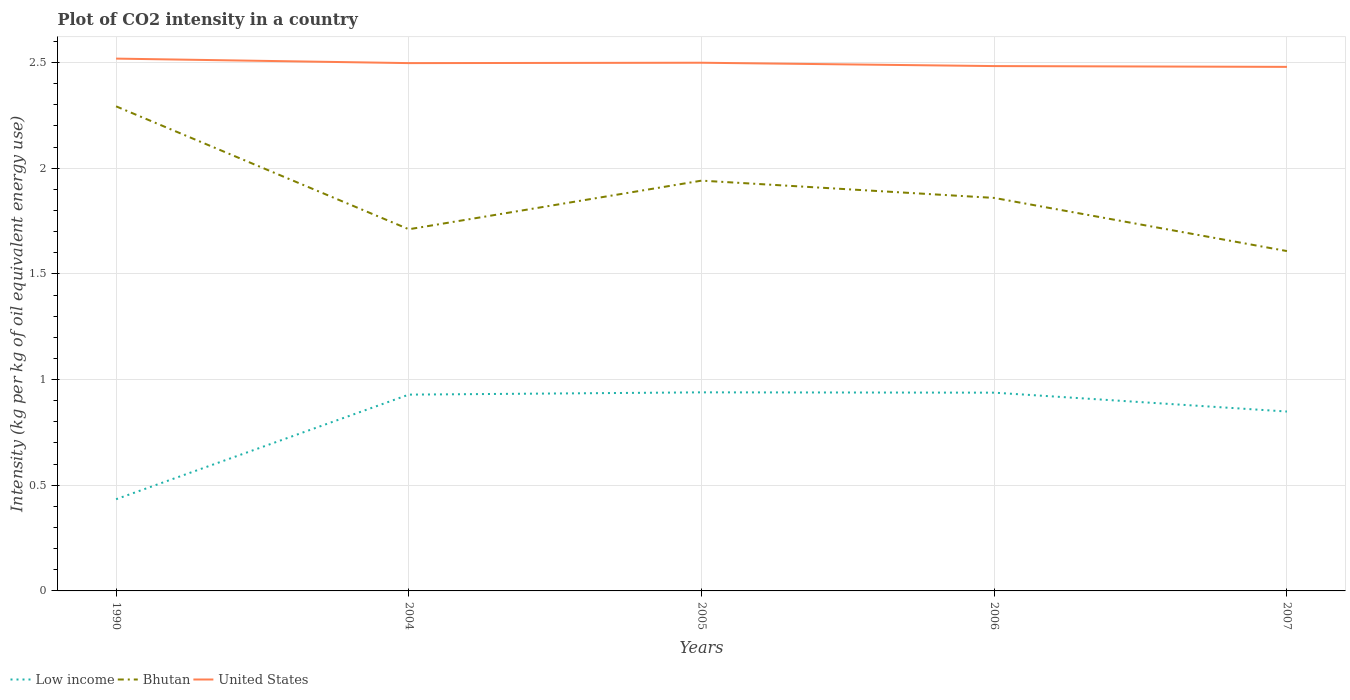How many different coloured lines are there?
Offer a very short reply. 3. Is the number of lines equal to the number of legend labels?
Make the answer very short. Yes. Across all years, what is the maximum CO2 intensity in in Low income?
Ensure brevity in your answer.  0.43. What is the total CO2 intensity in in Bhutan in the graph?
Provide a succinct answer. 0.58. What is the difference between the highest and the second highest CO2 intensity in in United States?
Your response must be concise. 0.04. What is the difference between the highest and the lowest CO2 intensity in in Bhutan?
Provide a short and direct response. 2. How many lines are there?
Ensure brevity in your answer.  3. What is the difference between two consecutive major ticks on the Y-axis?
Your answer should be compact. 0.5. Does the graph contain any zero values?
Offer a terse response. No. Does the graph contain grids?
Your response must be concise. Yes. Where does the legend appear in the graph?
Your answer should be very brief. Bottom left. How many legend labels are there?
Offer a terse response. 3. What is the title of the graph?
Your answer should be compact. Plot of CO2 intensity in a country. What is the label or title of the X-axis?
Your answer should be compact. Years. What is the label or title of the Y-axis?
Offer a very short reply. Intensity (kg per kg of oil equivalent energy use). What is the Intensity (kg per kg of oil equivalent energy use) of Low income in 1990?
Offer a very short reply. 0.43. What is the Intensity (kg per kg of oil equivalent energy use) of Bhutan in 1990?
Ensure brevity in your answer.  2.29. What is the Intensity (kg per kg of oil equivalent energy use) in United States in 1990?
Your response must be concise. 2.52. What is the Intensity (kg per kg of oil equivalent energy use) in Low income in 2004?
Provide a short and direct response. 0.93. What is the Intensity (kg per kg of oil equivalent energy use) of Bhutan in 2004?
Make the answer very short. 1.71. What is the Intensity (kg per kg of oil equivalent energy use) of United States in 2004?
Your answer should be very brief. 2.5. What is the Intensity (kg per kg of oil equivalent energy use) in Low income in 2005?
Provide a succinct answer. 0.94. What is the Intensity (kg per kg of oil equivalent energy use) in Bhutan in 2005?
Your answer should be very brief. 1.94. What is the Intensity (kg per kg of oil equivalent energy use) in United States in 2005?
Offer a very short reply. 2.5. What is the Intensity (kg per kg of oil equivalent energy use) of Low income in 2006?
Provide a succinct answer. 0.94. What is the Intensity (kg per kg of oil equivalent energy use) of Bhutan in 2006?
Offer a very short reply. 1.86. What is the Intensity (kg per kg of oil equivalent energy use) in United States in 2006?
Keep it short and to the point. 2.48. What is the Intensity (kg per kg of oil equivalent energy use) in Low income in 2007?
Your answer should be compact. 0.85. What is the Intensity (kg per kg of oil equivalent energy use) in Bhutan in 2007?
Your response must be concise. 1.61. What is the Intensity (kg per kg of oil equivalent energy use) of United States in 2007?
Provide a succinct answer. 2.48. Across all years, what is the maximum Intensity (kg per kg of oil equivalent energy use) of Low income?
Provide a succinct answer. 0.94. Across all years, what is the maximum Intensity (kg per kg of oil equivalent energy use) in Bhutan?
Your answer should be compact. 2.29. Across all years, what is the maximum Intensity (kg per kg of oil equivalent energy use) of United States?
Offer a very short reply. 2.52. Across all years, what is the minimum Intensity (kg per kg of oil equivalent energy use) in Low income?
Your answer should be very brief. 0.43. Across all years, what is the minimum Intensity (kg per kg of oil equivalent energy use) in Bhutan?
Your response must be concise. 1.61. Across all years, what is the minimum Intensity (kg per kg of oil equivalent energy use) of United States?
Your answer should be very brief. 2.48. What is the total Intensity (kg per kg of oil equivalent energy use) in Low income in the graph?
Your answer should be compact. 4.09. What is the total Intensity (kg per kg of oil equivalent energy use) in Bhutan in the graph?
Offer a very short reply. 9.41. What is the total Intensity (kg per kg of oil equivalent energy use) of United States in the graph?
Your response must be concise. 12.48. What is the difference between the Intensity (kg per kg of oil equivalent energy use) in Low income in 1990 and that in 2004?
Your response must be concise. -0.49. What is the difference between the Intensity (kg per kg of oil equivalent energy use) of Bhutan in 1990 and that in 2004?
Your response must be concise. 0.58. What is the difference between the Intensity (kg per kg of oil equivalent energy use) in United States in 1990 and that in 2004?
Keep it short and to the point. 0.02. What is the difference between the Intensity (kg per kg of oil equivalent energy use) of Low income in 1990 and that in 2005?
Ensure brevity in your answer.  -0.51. What is the difference between the Intensity (kg per kg of oil equivalent energy use) in Bhutan in 1990 and that in 2005?
Keep it short and to the point. 0.35. What is the difference between the Intensity (kg per kg of oil equivalent energy use) in United States in 1990 and that in 2005?
Offer a very short reply. 0.02. What is the difference between the Intensity (kg per kg of oil equivalent energy use) in Low income in 1990 and that in 2006?
Provide a short and direct response. -0.5. What is the difference between the Intensity (kg per kg of oil equivalent energy use) in Bhutan in 1990 and that in 2006?
Make the answer very short. 0.43. What is the difference between the Intensity (kg per kg of oil equivalent energy use) in United States in 1990 and that in 2006?
Offer a terse response. 0.04. What is the difference between the Intensity (kg per kg of oil equivalent energy use) in Low income in 1990 and that in 2007?
Your answer should be very brief. -0.41. What is the difference between the Intensity (kg per kg of oil equivalent energy use) in Bhutan in 1990 and that in 2007?
Your answer should be compact. 0.68. What is the difference between the Intensity (kg per kg of oil equivalent energy use) in United States in 1990 and that in 2007?
Keep it short and to the point. 0.04. What is the difference between the Intensity (kg per kg of oil equivalent energy use) of Low income in 2004 and that in 2005?
Provide a short and direct response. -0.01. What is the difference between the Intensity (kg per kg of oil equivalent energy use) in Bhutan in 2004 and that in 2005?
Keep it short and to the point. -0.23. What is the difference between the Intensity (kg per kg of oil equivalent energy use) in United States in 2004 and that in 2005?
Your answer should be very brief. -0. What is the difference between the Intensity (kg per kg of oil equivalent energy use) of Low income in 2004 and that in 2006?
Your response must be concise. -0.01. What is the difference between the Intensity (kg per kg of oil equivalent energy use) of Bhutan in 2004 and that in 2006?
Your answer should be compact. -0.15. What is the difference between the Intensity (kg per kg of oil equivalent energy use) of United States in 2004 and that in 2006?
Offer a very short reply. 0.01. What is the difference between the Intensity (kg per kg of oil equivalent energy use) in Bhutan in 2004 and that in 2007?
Your answer should be compact. 0.1. What is the difference between the Intensity (kg per kg of oil equivalent energy use) of United States in 2004 and that in 2007?
Ensure brevity in your answer.  0.02. What is the difference between the Intensity (kg per kg of oil equivalent energy use) in Low income in 2005 and that in 2006?
Provide a succinct answer. 0. What is the difference between the Intensity (kg per kg of oil equivalent energy use) of Bhutan in 2005 and that in 2006?
Provide a succinct answer. 0.08. What is the difference between the Intensity (kg per kg of oil equivalent energy use) of United States in 2005 and that in 2006?
Your answer should be very brief. 0.02. What is the difference between the Intensity (kg per kg of oil equivalent energy use) in Low income in 2005 and that in 2007?
Your answer should be very brief. 0.09. What is the difference between the Intensity (kg per kg of oil equivalent energy use) in Bhutan in 2005 and that in 2007?
Provide a short and direct response. 0.33. What is the difference between the Intensity (kg per kg of oil equivalent energy use) in United States in 2005 and that in 2007?
Keep it short and to the point. 0.02. What is the difference between the Intensity (kg per kg of oil equivalent energy use) in Low income in 2006 and that in 2007?
Provide a short and direct response. 0.09. What is the difference between the Intensity (kg per kg of oil equivalent energy use) of Bhutan in 2006 and that in 2007?
Your answer should be compact. 0.25. What is the difference between the Intensity (kg per kg of oil equivalent energy use) of United States in 2006 and that in 2007?
Provide a short and direct response. 0. What is the difference between the Intensity (kg per kg of oil equivalent energy use) in Low income in 1990 and the Intensity (kg per kg of oil equivalent energy use) in Bhutan in 2004?
Provide a succinct answer. -1.28. What is the difference between the Intensity (kg per kg of oil equivalent energy use) in Low income in 1990 and the Intensity (kg per kg of oil equivalent energy use) in United States in 2004?
Provide a succinct answer. -2.06. What is the difference between the Intensity (kg per kg of oil equivalent energy use) of Bhutan in 1990 and the Intensity (kg per kg of oil equivalent energy use) of United States in 2004?
Your answer should be very brief. -0.2. What is the difference between the Intensity (kg per kg of oil equivalent energy use) in Low income in 1990 and the Intensity (kg per kg of oil equivalent energy use) in Bhutan in 2005?
Provide a succinct answer. -1.51. What is the difference between the Intensity (kg per kg of oil equivalent energy use) in Low income in 1990 and the Intensity (kg per kg of oil equivalent energy use) in United States in 2005?
Your response must be concise. -2.07. What is the difference between the Intensity (kg per kg of oil equivalent energy use) of Bhutan in 1990 and the Intensity (kg per kg of oil equivalent energy use) of United States in 2005?
Make the answer very short. -0.21. What is the difference between the Intensity (kg per kg of oil equivalent energy use) in Low income in 1990 and the Intensity (kg per kg of oil equivalent energy use) in Bhutan in 2006?
Give a very brief answer. -1.43. What is the difference between the Intensity (kg per kg of oil equivalent energy use) in Low income in 1990 and the Intensity (kg per kg of oil equivalent energy use) in United States in 2006?
Offer a terse response. -2.05. What is the difference between the Intensity (kg per kg of oil equivalent energy use) of Bhutan in 1990 and the Intensity (kg per kg of oil equivalent energy use) of United States in 2006?
Your response must be concise. -0.19. What is the difference between the Intensity (kg per kg of oil equivalent energy use) of Low income in 1990 and the Intensity (kg per kg of oil equivalent energy use) of Bhutan in 2007?
Give a very brief answer. -1.17. What is the difference between the Intensity (kg per kg of oil equivalent energy use) in Low income in 1990 and the Intensity (kg per kg of oil equivalent energy use) in United States in 2007?
Provide a succinct answer. -2.05. What is the difference between the Intensity (kg per kg of oil equivalent energy use) in Bhutan in 1990 and the Intensity (kg per kg of oil equivalent energy use) in United States in 2007?
Your answer should be compact. -0.19. What is the difference between the Intensity (kg per kg of oil equivalent energy use) of Low income in 2004 and the Intensity (kg per kg of oil equivalent energy use) of Bhutan in 2005?
Offer a very short reply. -1.01. What is the difference between the Intensity (kg per kg of oil equivalent energy use) of Low income in 2004 and the Intensity (kg per kg of oil equivalent energy use) of United States in 2005?
Make the answer very short. -1.57. What is the difference between the Intensity (kg per kg of oil equivalent energy use) in Bhutan in 2004 and the Intensity (kg per kg of oil equivalent energy use) in United States in 2005?
Offer a very short reply. -0.79. What is the difference between the Intensity (kg per kg of oil equivalent energy use) in Low income in 2004 and the Intensity (kg per kg of oil equivalent energy use) in Bhutan in 2006?
Provide a succinct answer. -0.93. What is the difference between the Intensity (kg per kg of oil equivalent energy use) of Low income in 2004 and the Intensity (kg per kg of oil equivalent energy use) of United States in 2006?
Ensure brevity in your answer.  -1.55. What is the difference between the Intensity (kg per kg of oil equivalent energy use) in Bhutan in 2004 and the Intensity (kg per kg of oil equivalent energy use) in United States in 2006?
Provide a succinct answer. -0.77. What is the difference between the Intensity (kg per kg of oil equivalent energy use) of Low income in 2004 and the Intensity (kg per kg of oil equivalent energy use) of Bhutan in 2007?
Make the answer very short. -0.68. What is the difference between the Intensity (kg per kg of oil equivalent energy use) in Low income in 2004 and the Intensity (kg per kg of oil equivalent energy use) in United States in 2007?
Provide a succinct answer. -1.55. What is the difference between the Intensity (kg per kg of oil equivalent energy use) in Bhutan in 2004 and the Intensity (kg per kg of oil equivalent energy use) in United States in 2007?
Your answer should be compact. -0.77. What is the difference between the Intensity (kg per kg of oil equivalent energy use) in Low income in 2005 and the Intensity (kg per kg of oil equivalent energy use) in Bhutan in 2006?
Your response must be concise. -0.92. What is the difference between the Intensity (kg per kg of oil equivalent energy use) in Low income in 2005 and the Intensity (kg per kg of oil equivalent energy use) in United States in 2006?
Give a very brief answer. -1.54. What is the difference between the Intensity (kg per kg of oil equivalent energy use) of Bhutan in 2005 and the Intensity (kg per kg of oil equivalent energy use) of United States in 2006?
Your response must be concise. -0.54. What is the difference between the Intensity (kg per kg of oil equivalent energy use) in Low income in 2005 and the Intensity (kg per kg of oil equivalent energy use) in Bhutan in 2007?
Your answer should be very brief. -0.67. What is the difference between the Intensity (kg per kg of oil equivalent energy use) in Low income in 2005 and the Intensity (kg per kg of oil equivalent energy use) in United States in 2007?
Provide a succinct answer. -1.54. What is the difference between the Intensity (kg per kg of oil equivalent energy use) in Bhutan in 2005 and the Intensity (kg per kg of oil equivalent energy use) in United States in 2007?
Offer a very short reply. -0.54. What is the difference between the Intensity (kg per kg of oil equivalent energy use) of Low income in 2006 and the Intensity (kg per kg of oil equivalent energy use) of Bhutan in 2007?
Provide a succinct answer. -0.67. What is the difference between the Intensity (kg per kg of oil equivalent energy use) of Low income in 2006 and the Intensity (kg per kg of oil equivalent energy use) of United States in 2007?
Your response must be concise. -1.54. What is the difference between the Intensity (kg per kg of oil equivalent energy use) in Bhutan in 2006 and the Intensity (kg per kg of oil equivalent energy use) in United States in 2007?
Make the answer very short. -0.62. What is the average Intensity (kg per kg of oil equivalent energy use) of Low income per year?
Your answer should be very brief. 0.82. What is the average Intensity (kg per kg of oil equivalent energy use) in Bhutan per year?
Keep it short and to the point. 1.88. What is the average Intensity (kg per kg of oil equivalent energy use) of United States per year?
Provide a short and direct response. 2.5. In the year 1990, what is the difference between the Intensity (kg per kg of oil equivalent energy use) of Low income and Intensity (kg per kg of oil equivalent energy use) of Bhutan?
Ensure brevity in your answer.  -1.86. In the year 1990, what is the difference between the Intensity (kg per kg of oil equivalent energy use) of Low income and Intensity (kg per kg of oil equivalent energy use) of United States?
Provide a short and direct response. -2.08. In the year 1990, what is the difference between the Intensity (kg per kg of oil equivalent energy use) in Bhutan and Intensity (kg per kg of oil equivalent energy use) in United States?
Offer a very short reply. -0.23. In the year 2004, what is the difference between the Intensity (kg per kg of oil equivalent energy use) in Low income and Intensity (kg per kg of oil equivalent energy use) in Bhutan?
Offer a terse response. -0.78. In the year 2004, what is the difference between the Intensity (kg per kg of oil equivalent energy use) of Low income and Intensity (kg per kg of oil equivalent energy use) of United States?
Keep it short and to the point. -1.57. In the year 2004, what is the difference between the Intensity (kg per kg of oil equivalent energy use) in Bhutan and Intensity (kg per kg of oil equivalent energy use) in United States?
Provide a succinct answer. -0.79. In the year 2005, what is the difference between the Intensity (kg per kg of oil equivalent energy use) of Low income and Intensity (kg per kg of oil equivalent energy use) of Bhutan?
Give a very brief answer. -1. In the year 2005, what is the difference between the Intensity (kg per kg of oil equivalent energy use) of Low income and Intensity (kg per kg of oil equivalent energy use) of United States?
Your answer should be compact. -1.56. In the year 2005, what is the difference between the Intensity (kg per kg of oil equivalent energy use) in Bhutan and Intensity (kg per kg of oil equivalent energy use) in United States?
Your answer should be very brief. -0.56. In the year 2006, what is the difference between the Intensity (kg per kg of oil equivalent energy use) in Low income and Intensity (kg per kg of oil equivalent energy use) in Bhutan?
Provide a succinct answer. -0.92. In the year 2006, what is the difference between the Intensity (kg per kg of oil equivalent energy use) in Low income and Intensity (kg per kg of oil equivalent energy use) in United States?
Make the answer very short. -1.55. In the year 2006, what is the difference between the Intensity (kg per kg of oil equivalent energy use) of Bhutan and Intensity (kg per kg of oil equivalent energy use) of United States?
Your answer should be compact. -0.62. In the year 2007, what is the difference between the Intensity (kg per kg of oil equivalent energy use) of Low income and Intensity (kg per kg of oil equivalent energy use) of Bhutan?
Provide a short and direct response. -0.76. In the year 2007, what is the difference between the Intensity (kg per kg of oil equivalent energy use) of Low income and Intensity (kg per kg of oil equivalent energy use) of United States?
Your response must be concise. -1.63. In the year 2007, what is the difference between the Intensity (kg per kg of oil equivalent energy use) of Bhutan and Intensity (kg per kg of oil equivalent energy use) of United States?
Your answer should be very brief. -0.87. What is the ratio of the Intensity (kg per kg of oil equivalent energy use) of Low income in 1990 to that in 2004?
Ensure brevity in your answer.  0.47. What is the ratio of the Intensity (kg per kg of oil equivalent energy use) in Bhutan in 1990 to that in 2004?
Keep it short and to the point. 1.34. What is the ratio of the Intensity (kg per kg of oil equivalent energy use) of United States in 1990 to that in 2004?
Ensure brevity in your answer.  1.01. What is the ratio of the Intensity (kg per kg of oil equivalent energy use) of Low income in 1990 to that in 2005?
Your response must be concise. 0.46. What is the ratio of the Intensity (kg per kg of oil equivalent energy use) of Bhutan in 1990 to that in 2005?
Provide a short and direct response. 1.18. What is the ratio of the Intensity (kg per kg of oil equivalent energy use) of Low income in 1990 to that in 2006?
Provide a succinct answer. 0.46. What is the ratio of the Intensity (kg per kg of oil equivalent energy use) of Bhutan in 1990 to that in 2006?
Keep it short and to the point. 1.23. What is the ratio of the Intensity (kg per kg of oil equivalent energy use) of United States in 1990 to that in 2006?
Offer a terse response. 1.01. What is the ratio of the Intensity (kg per kg of oil equivalent energy use) of Low income in 1990 to that in 2007?
Provide a succinct answer. 0.51. What is the ratio of the Intensity (kg per kg of oil equivalent energy use) in Bhutan in 1990 to that in 2007?
Provide a succinct answer. 1.43. What is the ratio of the Intensity (kg per kg of oil equivalent energy use) in United States in 1990 to that in 2007?
Your response must be concise. 1.02. What is the ratio of the Intensity (kg per kg of oil equivalent energy use) in Low income in 2004 to that in 2005?
Keep it short and to the point. 0.99. What is the ratio of the Intensity (kg per kg of oil equivalent energy use) of Bhutan in 2004 to that in 2005?
Your answer should be compact. 0.88. What is the ratio of the Intensity (kg per kg of oil equivalent energy use) in United States in 2004 to that in 2005?
Keep it short and to the point. 1. What is the ratio of the Intensity (kg per kg of oil equivalent energy use) in Bhutan in 2004 to that in 2006?
Keep it short and to the point. 0.92. What is the ratio of the Intensity (kg per kg of oil equivalent energy use) in Low income in 2004 to that in 2007?
Make the answer very short. 1.09. What is the ratio of the Intensity (kg per kg of oil equivalent energy use) of Bhutan in 2004 to that in 2007?
Ensure brevity in your answer.  1.06. What is the ratio of the Intensity (kg per kg of oil equivalent energy use) in Bhutan in 2005 to that in 2006?
Your answer should be compact. 1.04. What is the ratio of the Intensity (kg per kg of oil equivalent energy use) in United States in 2005 to that in 2006?
Give a very brief answer. 1.01. What is the ratio of the Intensity (kg per kg of oil equivalent energy use) in Low income in 2005 to that in 2007?
Provide a short and direct response. 1.11. What is the ratio of the Intensity (kg per kg of oil equivalent energy use) in Bhutan in 2005 to that in 2007?
Give a very brief answer. 1.21. What is the ratio of the Intensity (kg per kg of oil equivalent energy use) of United States in 2005 to that in 2007?
Provide a short and direct response. 1.01. What is the ratio of the Intensity (kg per kg of oil equivalent energy use) in Low income in 2006 to that in 2007?
Offer a terse response. 1.11. What is the ratio of the Intensity (kg per kg of oil equivalent energy use) of Bhutan in 2006 to that in 2007?
Your response must be concise. 1.16. What is the ratio of the Intensity (kg per kg of oil equivalent energy use) of United States in 2006 to that in 2007?
Provide a succinct answer. 1. What is the difference between the highest and the second highest Intensity (kg per kg of oil equivalent energy use) of Low income?
Make the answer very short. 0. What is the difference between the highest and the second highest Intensity (kg per kg of oil equivalent energy use) in Bhutan?
Provide a short and direct response. 0.35. What is the difference between the highest and the second highest Intensity (kg per kg of oil equivalent energy use) of United States?
Your answer should be very brief. 0.02. What is the difference between the highest and the lowest Intensity (kg per kg of oil equivalent energy use) in Low income?
Offer a very short reply. 0.51. What is the difference between the highest and the lowest Intensity (kg per kg of oil equivalent energy use) in Bhutan?
Your answer should be very brief. 0.68. What is the difference between the highest and the lowest Intensity (kg per kg of oil equivalent energy use) in United States?
Keep it short and to the point. 0.04. 